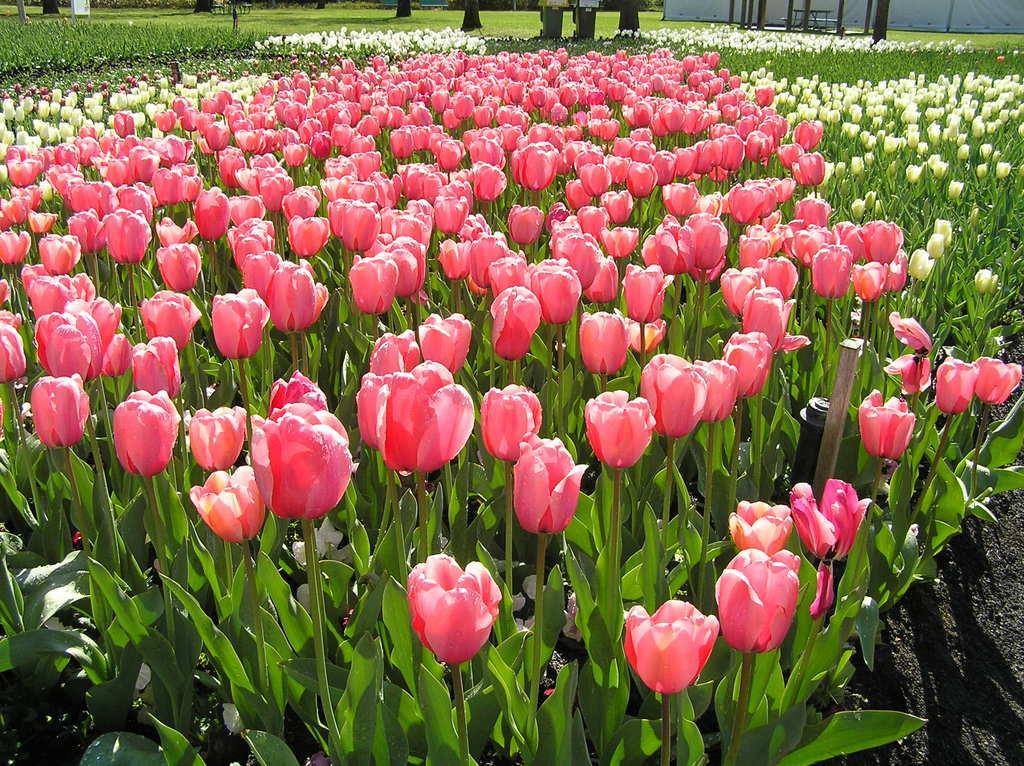Can you describe this image briefly? In this image there are few plants having different colors of flowers. Top of the image there are few tree trunks and poles on the grassland. Right top there is a wall. 